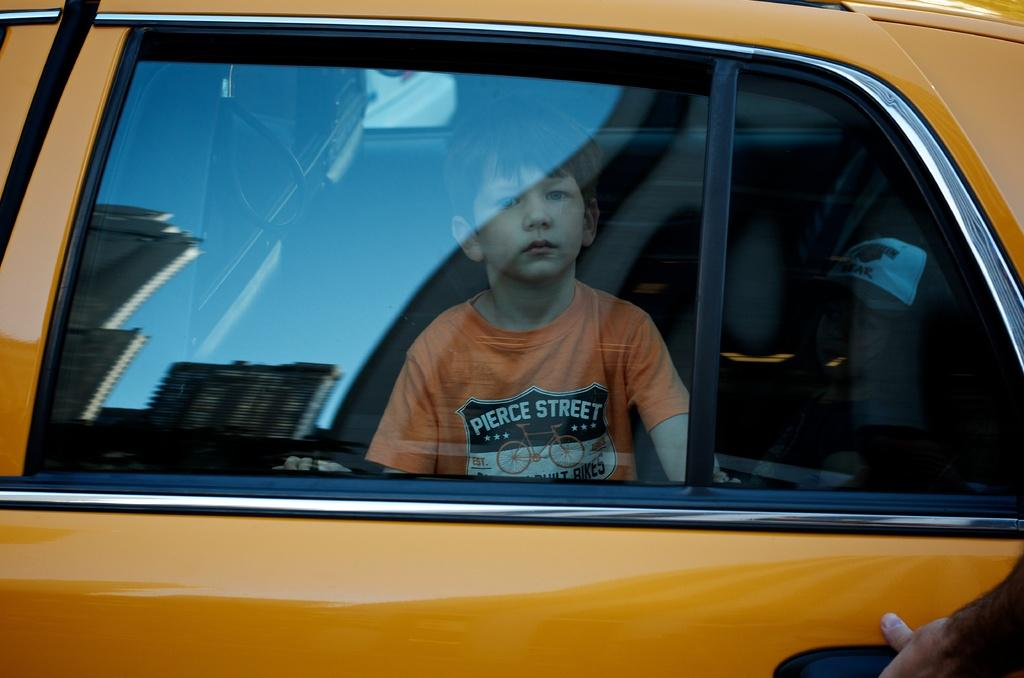Provide a one-sentence caption for the provided image. a boy with a shirt that says Pierce street sits in a taxi. 